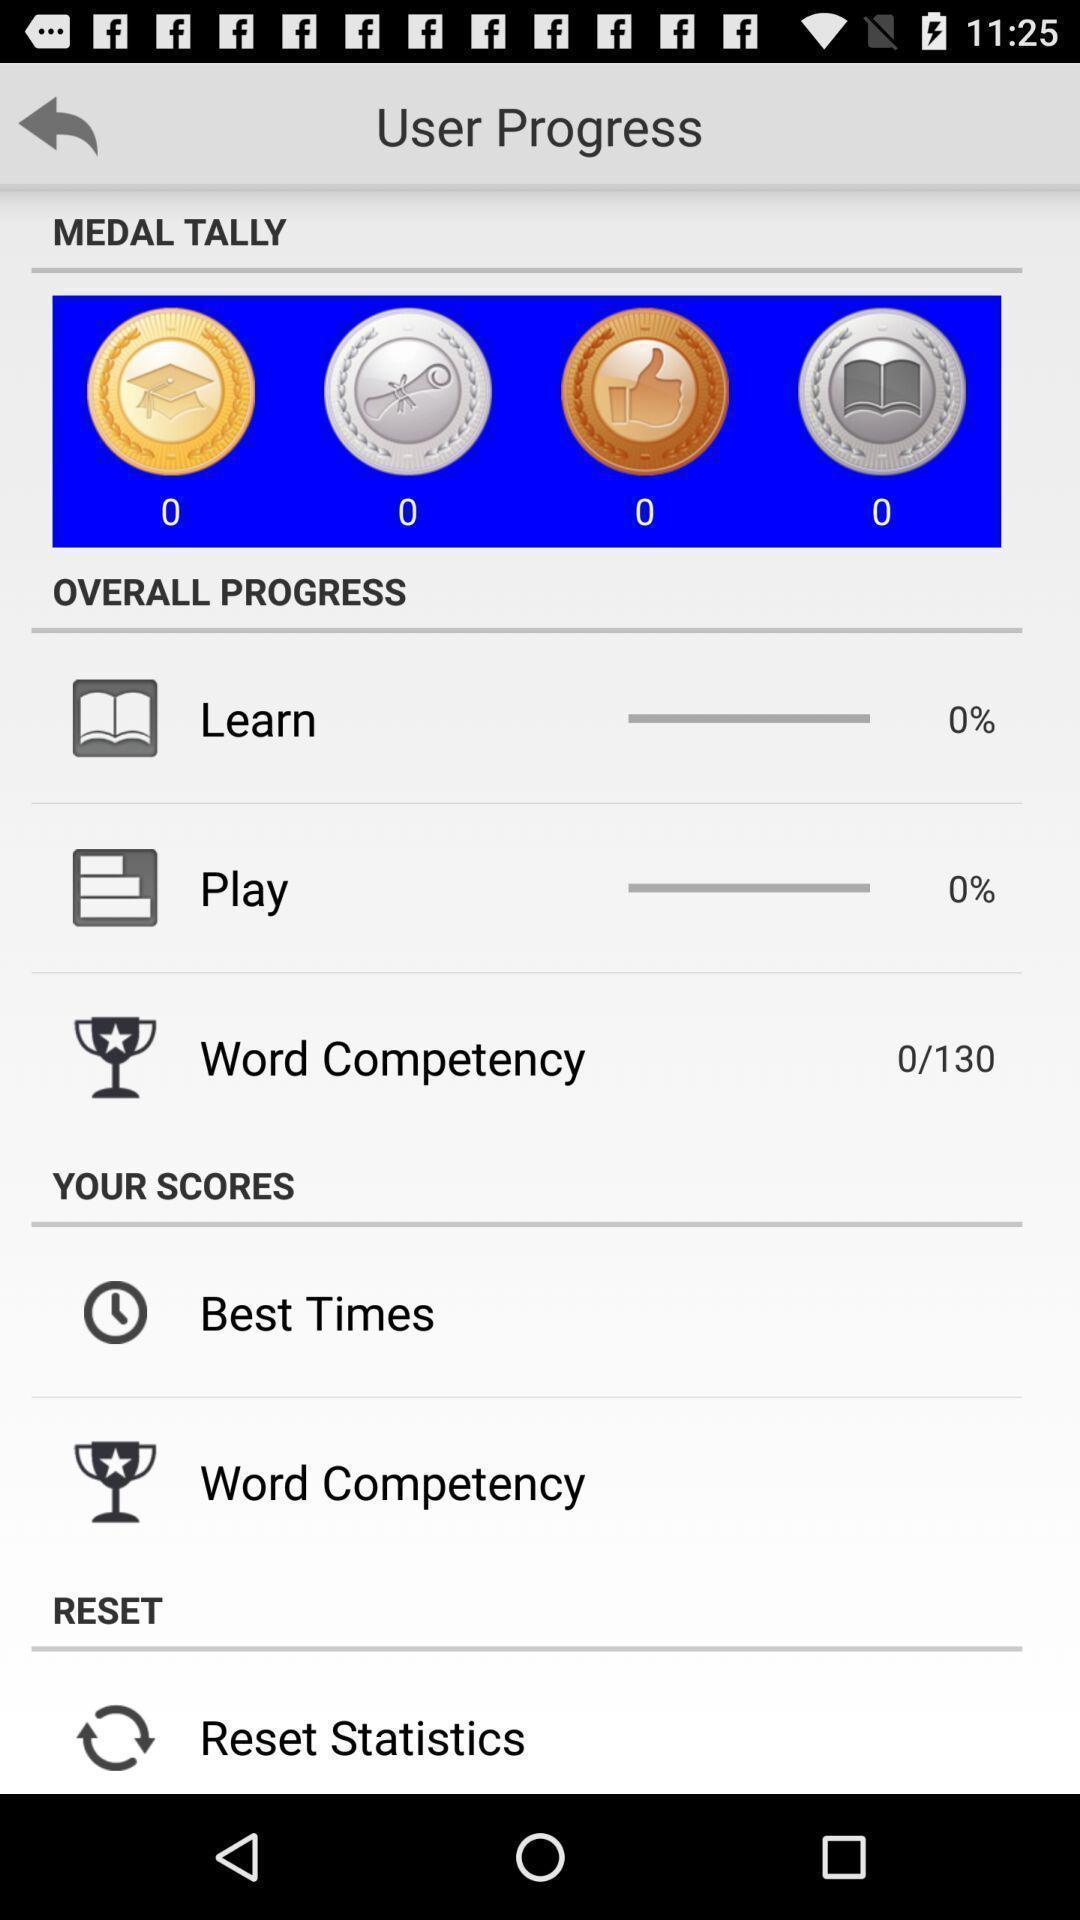What is the overall content of this screenshot? Page with overall progress. 